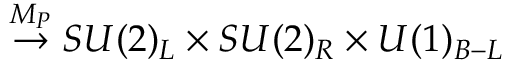<formula> <loc_0><loc_0><loc_500><loc_500>\stackrel { M _ { P } } { \rightarrow } S U ( 2 ) _ { L } \times S U ( 2 ) _ { R } \times U ( 1 ) _ { B - L }</formula> 